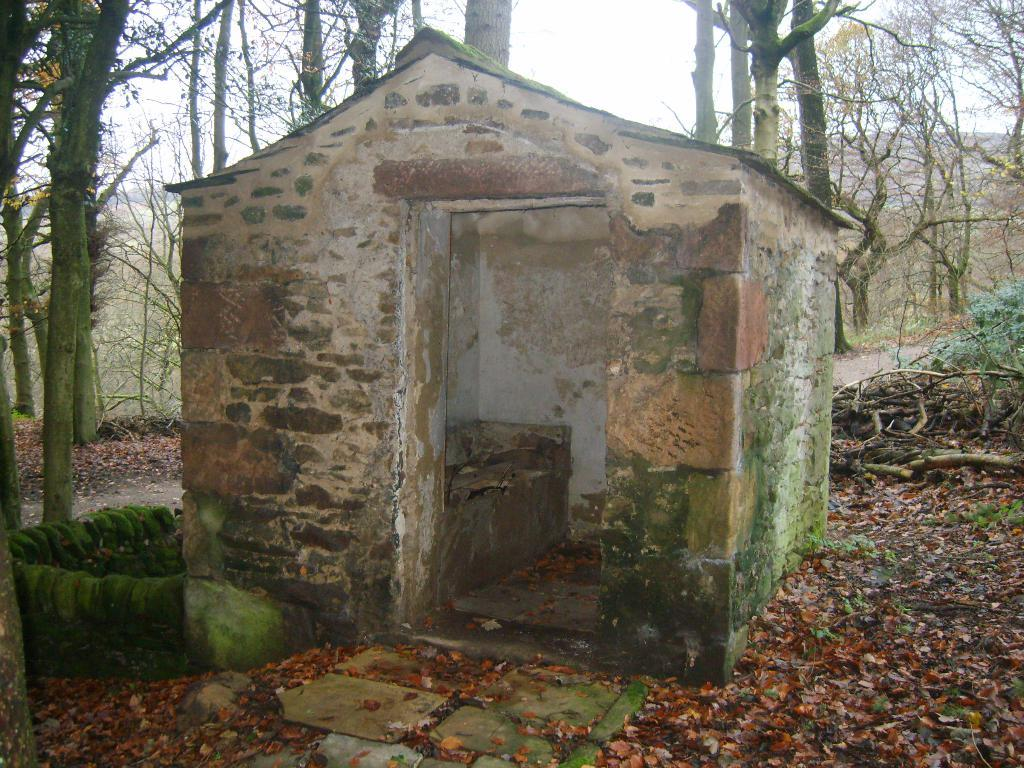What type of building is in the image? There is an old house in the image. What is covering the house? There is algae on the house. What type of vegetation is around the house? There are trees and plants around the house. What can be seen on the ground in the image? There are dry leaves on the surface in the image. What type of bait is being used to catch fish near the dock in the image? There is no dock or fishing activity present in the image; it features an old house surrounded by trees, plants, and dry leaves. 